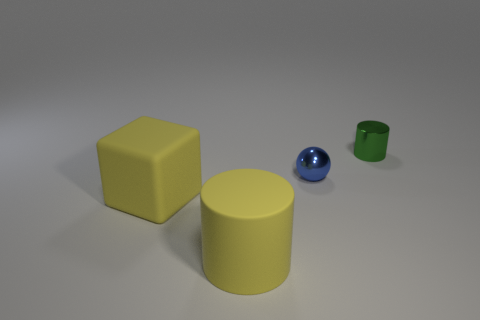What shape is the big object that is the same color as the large matte cube?
Your response must be concise. Cylinder. What number of balls are either purple metallic objects or big yellow rubber objects?
Provide a succinct answer. 0. Do the green shiny cylinder and the cylinder that is in front of the small metallic ball have the same size?
Your response must be concise. No. Is the number of tiny blue objects to the right of the green shiny cylinder greater than the number of cyan metal spheres?
Provide a short and direct response. No. There is another thing that is the same material as the tiny green thing; what is its size?
Provide a succinct answer. Small. Is there another large matte cylinder that has the same color as the rubber cylinder?
Offer a terse response. No. What number of things are red blocks or matte things that are behind the yellow rubber cylinder?
Your answer should be compact. 1. Is the number of yellow cylinders greater than the number of tiny green cubes?
Your response must be concise. Yes. The rubber object that is the same color as the large cube is what size?
Your answer should be very brief. Large. Are there any red objects made of the same material as the big cylinder?
Keep it short and to the point. No. 